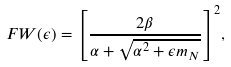Convert formula to latex. <formula><loc_0><loc_0><loc_500><loc_500>F W ( \epsilon ) = { \left [ \frac { 2 \beta } { \alpha + \sqrt { { \alpha } ^ { 2 } + \epsilon m _ { N } } } \right ] } ^ { 2 } ,</formula> 